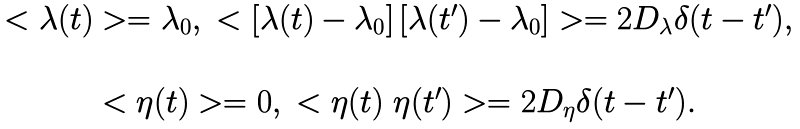Convert formula to latex. <formula><loc_0><loc_0><loc_500><loc_500>\begin{array} { c } < \lambda ( t ) > = \lambda _ { 0 } , \ < \left [ \lambda ( t ) - \lambda _ { 0 } \right ] \left [ \lambda ( t ^ { \prime } ) - \lambda _ { 0 } \right ] > = 2 D _ { \lambda } \delta ( t - t ^ { \prime } ) , \\ \\ < \eta ( t ) > = 0 , \ < \eta ( t ) \ \eta ( t ^ { \prime } ) > = 2 D _ { \eta } \delta ( t - t ^ { \prime } ) . \end{array}</formula> 